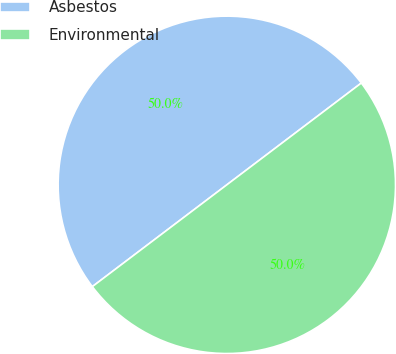Convert chart to OTSL. <chart><loc_0><loc_0><loc_500><loc_500><pie_chart><fcel>Asbestos<fcel>Environmental<nl><fcel>50.0%<fcel>50.0%<nl></chart> 